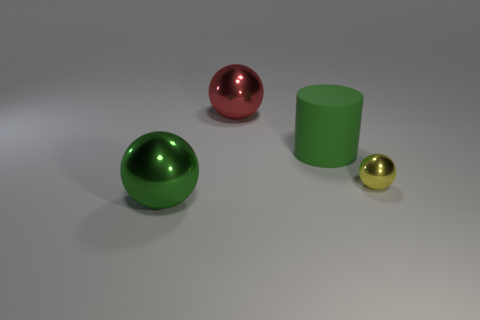Add 1 tiny green blocks. How many objects exist? 5 Subtract all spheres. How many objects are left? 1 Subtract 0 gray spheres. How many objects are left? 4 Subtract all tiny shiny balls. Subtract all large balls. How many objects are left? 1 Add 2 big green cylinders. How many big green cylinders are left? 3 Add 3 large purple cylinders. How many large purple cylinders exist? 3 